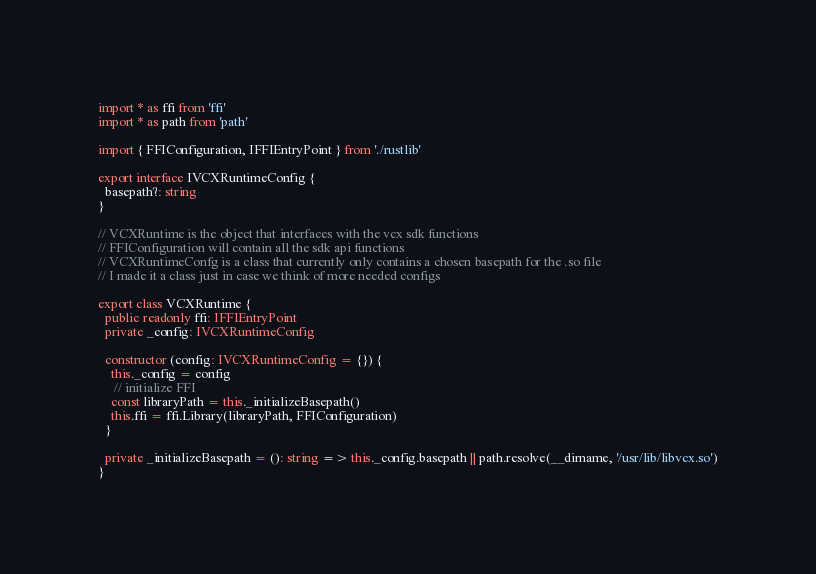Convert code to text. <code><loc_0><loc_0><loc_500><loc_500><_TypeScript_>import * as ffi from 'ffi'
import * as path from 'path'

import { FFIConfiguration, IFFIEntryPoint } from './rustlib'

export interface IVCXRuntimeConfig {
  basepath?: string
}

// VCXRuntime is the object that interfaces with the vcx sdk functions
// FFIConfiguration will contain all the sdk api functions
// VCXRuntimeConfg is a class that currently only contains a chosen basepath for the .so file
// I made it a class just in case we think of more needed configs

export class VCXRuntime {
  public readonly ffi: IFFIEntryPoint
  private _config: IVCXRuntimeConfig

  constructor (config: IVCXRuntimeConfig = {}) {
    this._config = config
     // initialize FFI
    const libraryPath = this._initializeBasepath()
    this.ffi = ffi.Library(libraryPath, FFIConfiguration)
  }

  private _initializeBasepath = (): string => this._config.basepath || path.resolve(__dirname, '/usr/lib/libvcx.so')
}
</code> 